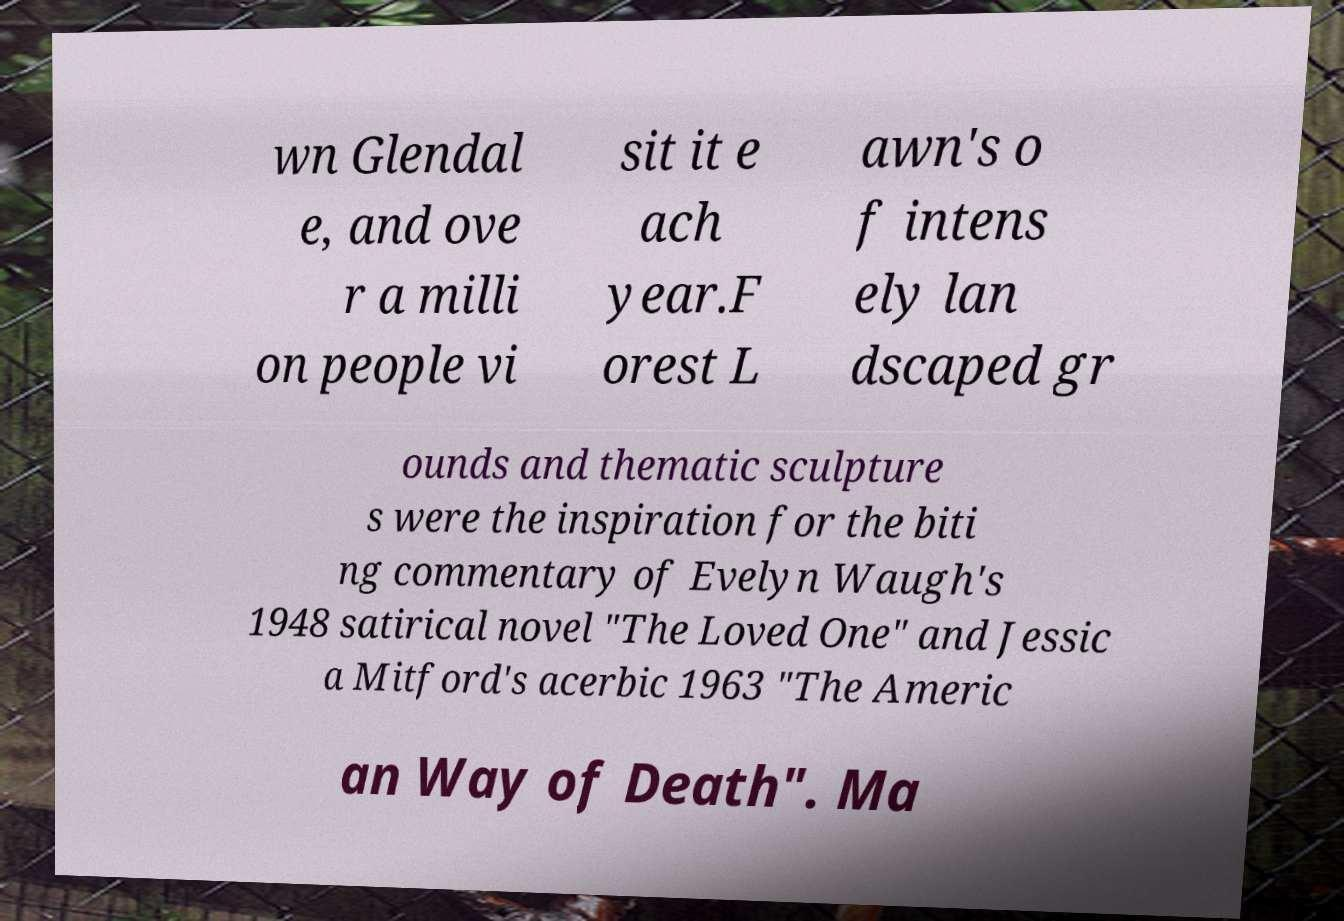Could you extract and type out the text from this image? wn Glendal e, and ove r a milli on people vi sit it e ach year.F orest L awn's o f intens ely lan dscaped gr ounds and thematic sculpture s were the inspiration for the biti ng commentary of Evelyn Waugh's 1948 satirical novel "The Loved One" and Jessic a Mitford's acerbic 1963 "The Americ an Way of Death". Ma 